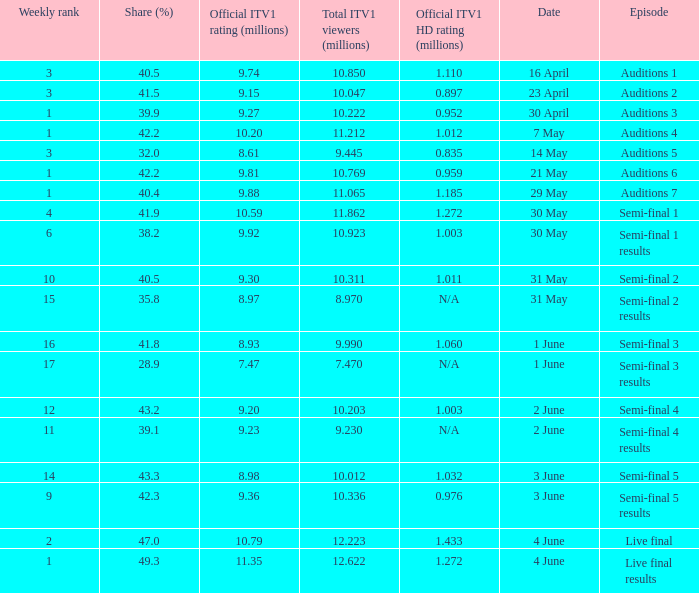Can you parse all the data within this table? {'header': ['Weekly rank', 'Share (%)', 'Official ITV1 rating (millions)', 'Total ITV1 viewers (millions)', 'Official ITV1 HD rating (millions)', 'Date', 'Episode'], 'rows': [['3', '40.5', '9.74', '10.850', '1.110', '16 April', 'Auditions 1'], ['3', '41.5', '9.15', '10.047', '0.897', '23 April', 'Auditions 2'], ['1', '39.9', '9.27', '10.222', '0.952', '30 April', 'Auditions 3'], ['1', '42.2', '10.20', '11.212', '1.012', '7 May', 'Auditions 4'], ['3', '32.0', '8.61', '9.445', '0.835', '14 May', 'Auditions 5'], ['1', '42.2', '9.81', '10.769', '0.959', '21 May', 'Auditions 6'], ['1', '40.4', '9.88', '11.065', '1.185', '29 May', 'Auditions 7'], ['4', '41.9', '10.59', '11.862', '1.272', '30 May', 'Semi-final 1'], ['6', '38.2', '9.92', '10.923', '1.003', '30 May', 'Semi-final 1 results'], ['10', '40.5', '9.30', '10.311', '1.011', '31 May', 'Semi-final 2'], ['15', '35.8', '8.97', '8.970', 'N/A', '31 May', 'Semi-final 2 results'], ['16', '41.8', '8.93', '9.990', '1.060', '1 June', 'Semi-final 3'], ['17', '28.9', '7.47', '7.470', 'N/A', '1 June', 'Semi-final 3 results'], ['12', '43.2', '9.20', '10.203', '1.003', '2 June', 'Semi-final 4'], ['11', '39.1', '9.23', '9.230', 'N/A', '2 June', 'Semi-final 4 results'], ['14', '43.3', '8.98', '10.012', '1.032', '3 June', 'Semi-final 5'], ['9', '42.3', '9.36', '10.336', '0.976', '3 June', 'Semi-final 5 results'], ['2', '47.0', '10.79', '12.223', '1.433', '4 June', 'Live final'], ['1', '49.3', '11.35', '12.622', '1.272', '4 June', 'Live final results']]} When was the episode that had a share (%) of 41.5? 23 April. 